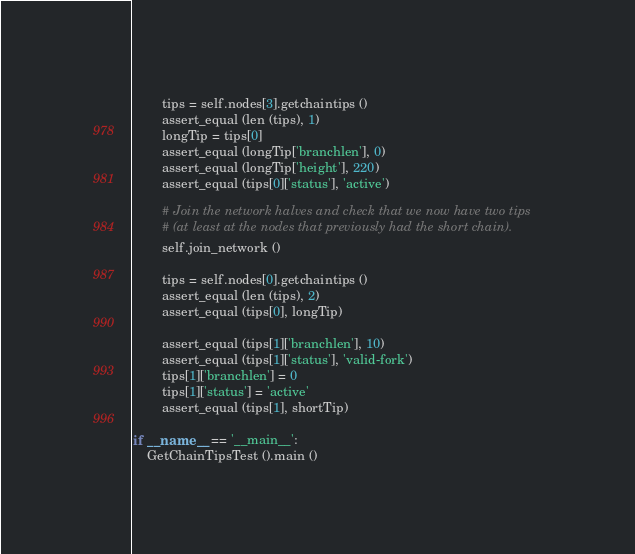<code> <loc_0><loc_0><loc_500><loc_500><_Python_>
        tips = self.nodes[3].getchaintips ()
        assert_equal (len (tips), 1)
        longTip = tips[0]
        assert_equal (longTip['branchlen'], 0)
        assert_equal (longTip['height'], 220)
        assert_equal (tips[0]['status'], 'active')

        # Join the network halves and check that we now have two tips
        # (at least at the nodes that previously had the short chain).
        self.join_network ()

        tips = self.nodes[0].getchaintips ()
        assert_equal (len (tips), 2)
        assert_equal (tips[0], longTip)

        assert_equal (tips[1]['branchlen'], 10)
        assert_equal (tips[1]['status'], 'valid-fork')
        tips[1]['branchlen'] = 0
        tips[1]['status'] = 'active'
        assert_equal (tips[1], shortTip)

if __name__ == '__main__':
    GetChainTipsTest ().main ()
</code> 